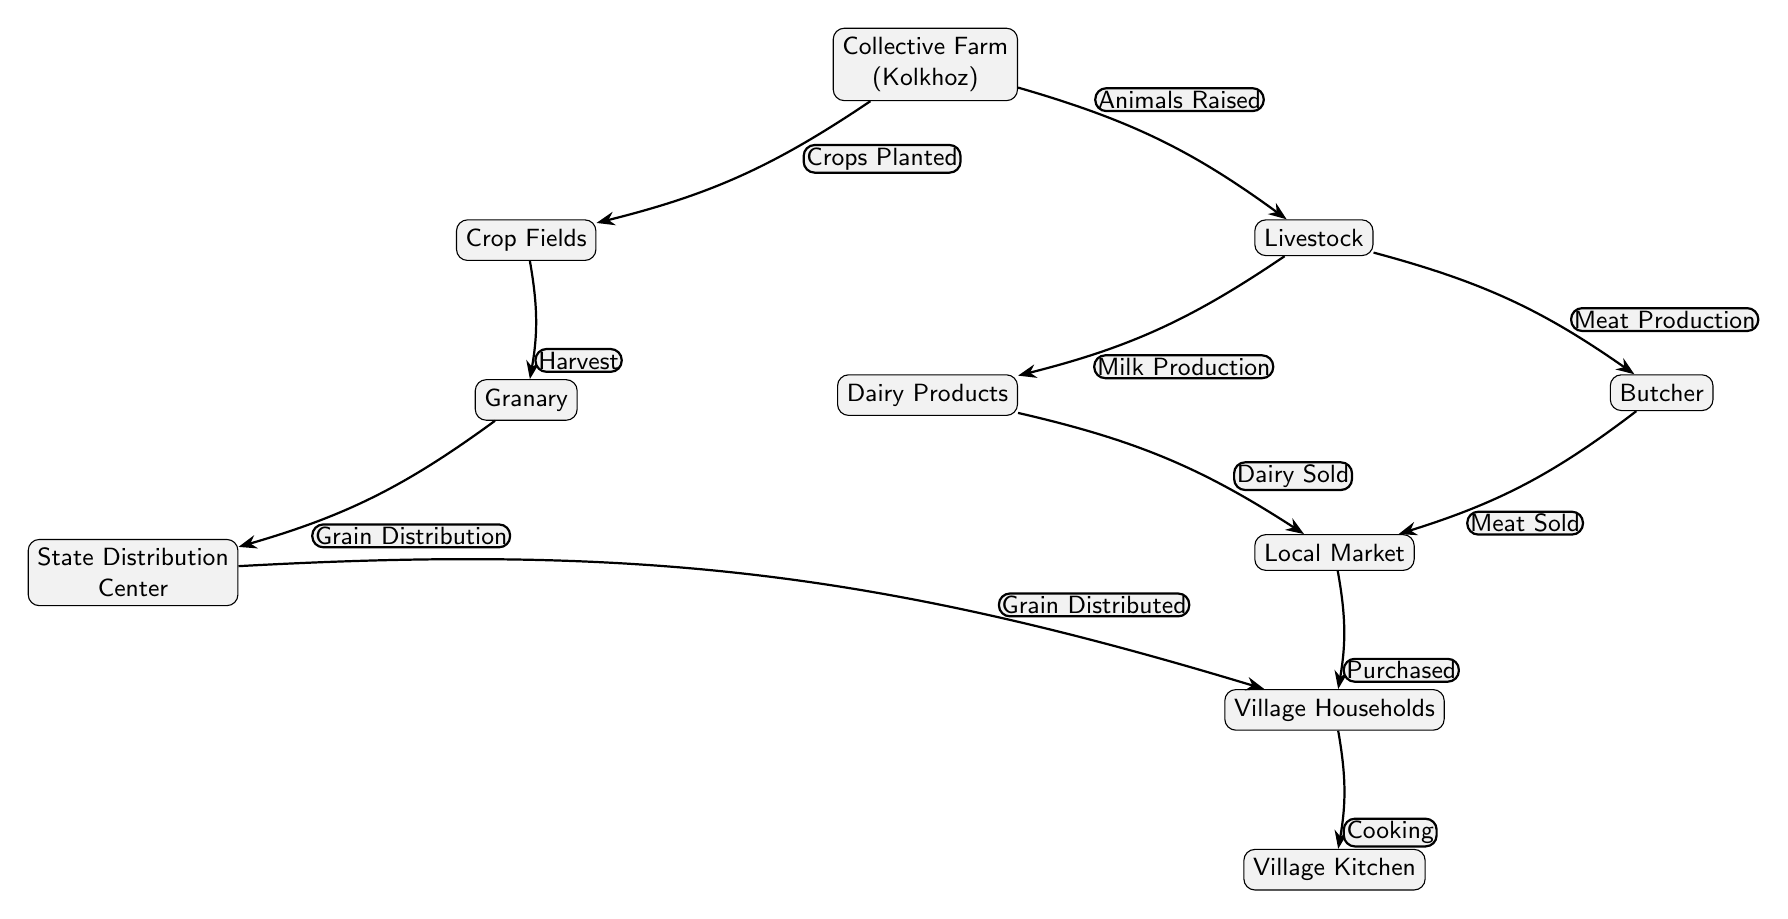What is the starting point of the food chain? The diagram begins with "Collective Farm (Kolkhoz)" as the starting point where crops are planted and livestock is raised.
Answer: Collective Farm (Kolkhoz) How many main sources of food are represented in the diagram? The diagram shows two main sources of food: crops from the field and livestock.
Answer: Two What happens to the crops after the harvest? After the harvest, the crops are sent to the granary for storage before distribution.
Answer: Granary Which node represents the sale of dairy products? The "Local Market" node represents where dairy products are sold after production.
Answer: Local Market What is the relationship between "Butcher" and "Local Market"? The "Butcher" node has a direct edge labeled "Meat Sold" leading to the "Local Market," indicating the sale of meat.
Answer: Meat Sold How do village households receive grain? Village households receive grain from the State Distribution Center, which distributes grain collected from the granary.
Answer: Grain Distributed What process follows after the "Households" node? Cooking follows after the households have gathered their food, leading to the "Village Kitchen."
Answer: Village Kitchen What comes before "Dairy Products" in the food chain? "Livestock" is the predecessor to "Dairy Products," as dairy is produced from the livestock.
Answer: Livestock How many distribution pathways flow from the "Local Market"? There is one distribution pathway from the Local Market leading to the Village Households labeled "Purchased."
Answer: One What action is performed in the "Village Kitchen"? The final action in the food chain is "Cooking," which occurs in the "Village Kitchen."
Answer: Cooking 